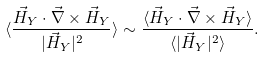Convert formula to latex. <formula><loc_0><loc_0><loc_500><loc_500>\langle \frac { \vec { H } _ { Y } \cdot \vec { \nabla } \times \vec { H } _ { Y } } { | \vec { H } _ { Y } | ^ { 2 } } \rangle \sim \frac { \langle \vec { H } _ { Y } \cdot \vec { \nabla } \times \vec { H } _ { Y } \rangle } { \langle | \vec { H } _ { Y } | ^ { 2 } \rangle } .</formula> 